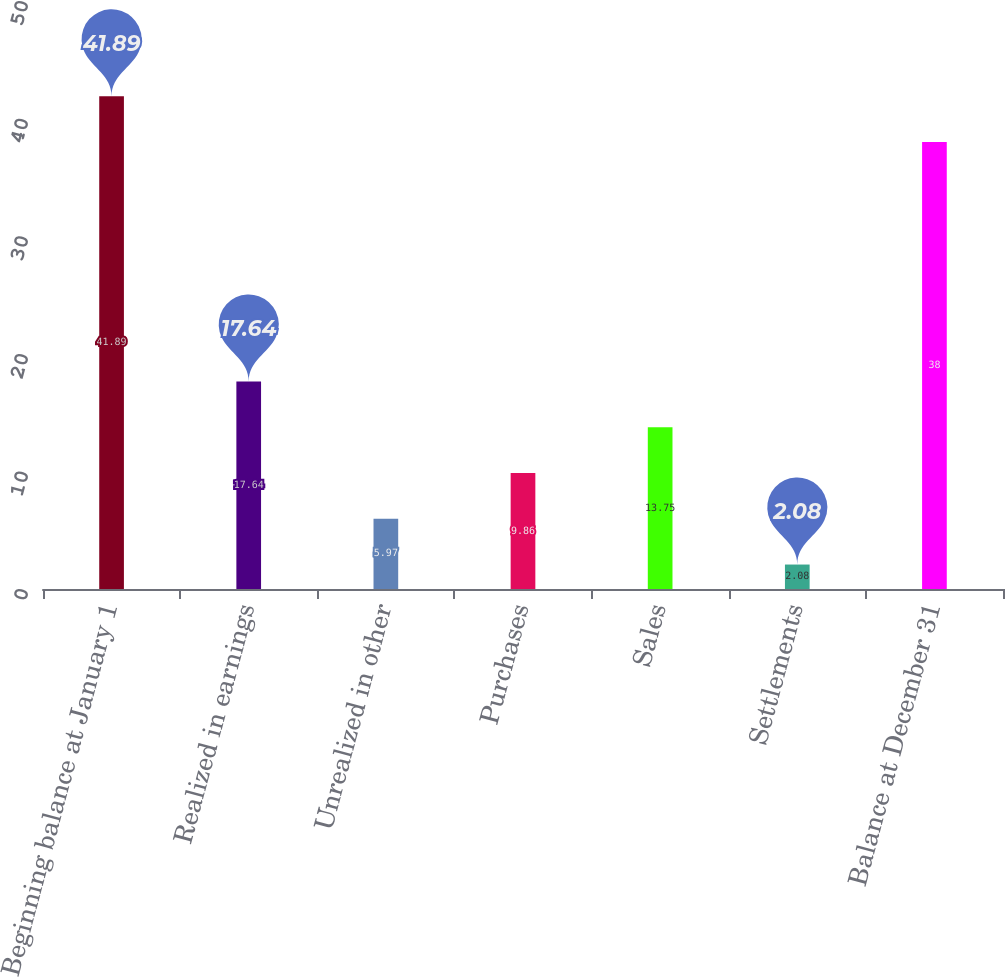Convert chart to OTSL. <chart><loc_0><loc_0><loc_500><loc_500><bar_chart><fcel>Beginning balance at January 1<fcel>Realized in earnings<fcel>Unrealized in other<fcel>Purchases<fcel>Sales<fcel>Settlements<fcel>Balance at December 31<nl><fcel>41.89<fcel>17.64<fcel>5.97<fcel>9.86<fcel>13.75<fcel>2.08<fcel>38<nl></chart> 